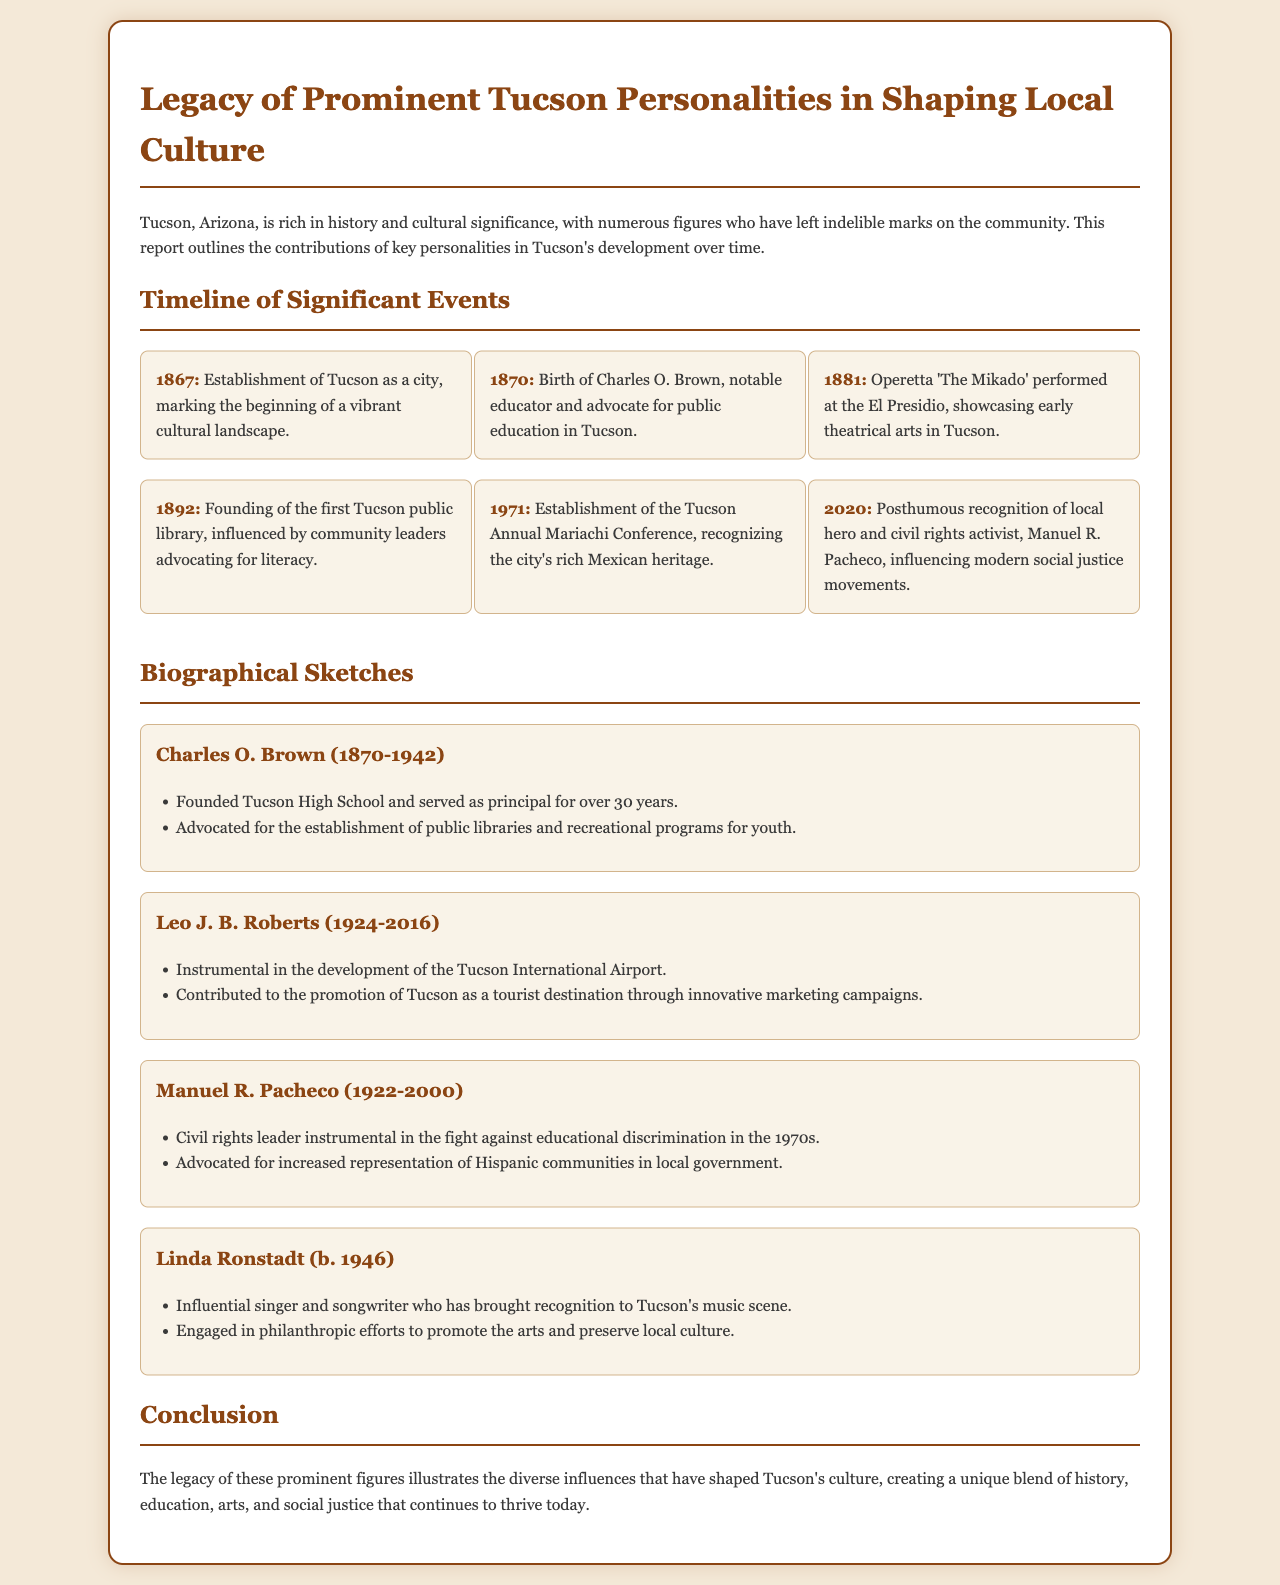What year was Tucson established as a city? The document states the establishment of Tucson as a city occurred in 1867.
Answer: 1867 Who was born in 1870 and advocated for public education? The document mentions Charles O. Brown, who was born in 1870 and advocated for public education in Tucson.
Answer: Charles O. Brown What significant event occurred in Tucson in 1971? According to the document, the Tucson Annual Mariachi Conference was established in 1971.
Answer: Tucson Annual Mariachi Conference Who founded Tucson High School? The document outlines that Charles O. Brown founded Tucson High School.
Answer: Charles O. Brown What is the relevance of Manuel R. Pacheco in the document? The document describes him as a civil rights leader instrumental in the fight against educational discrimination.
Answer: Civil rights leader How many years did Charles O. Brown serve as principal? The document states that he served as principal for over 30 years at Tucson High School.
Answer: Over 30 years What is the main focus of this report? The report centers on the legacy of prominent figures in Tucson who have shaped the local culture.
Answer: Legacy of prominent figures What type of art was showcased at the El Presidio in 1881? The document notes that the operetta 'The Mikado' was performed, showcasing early theatrical arts.
Answer: The Mikado 